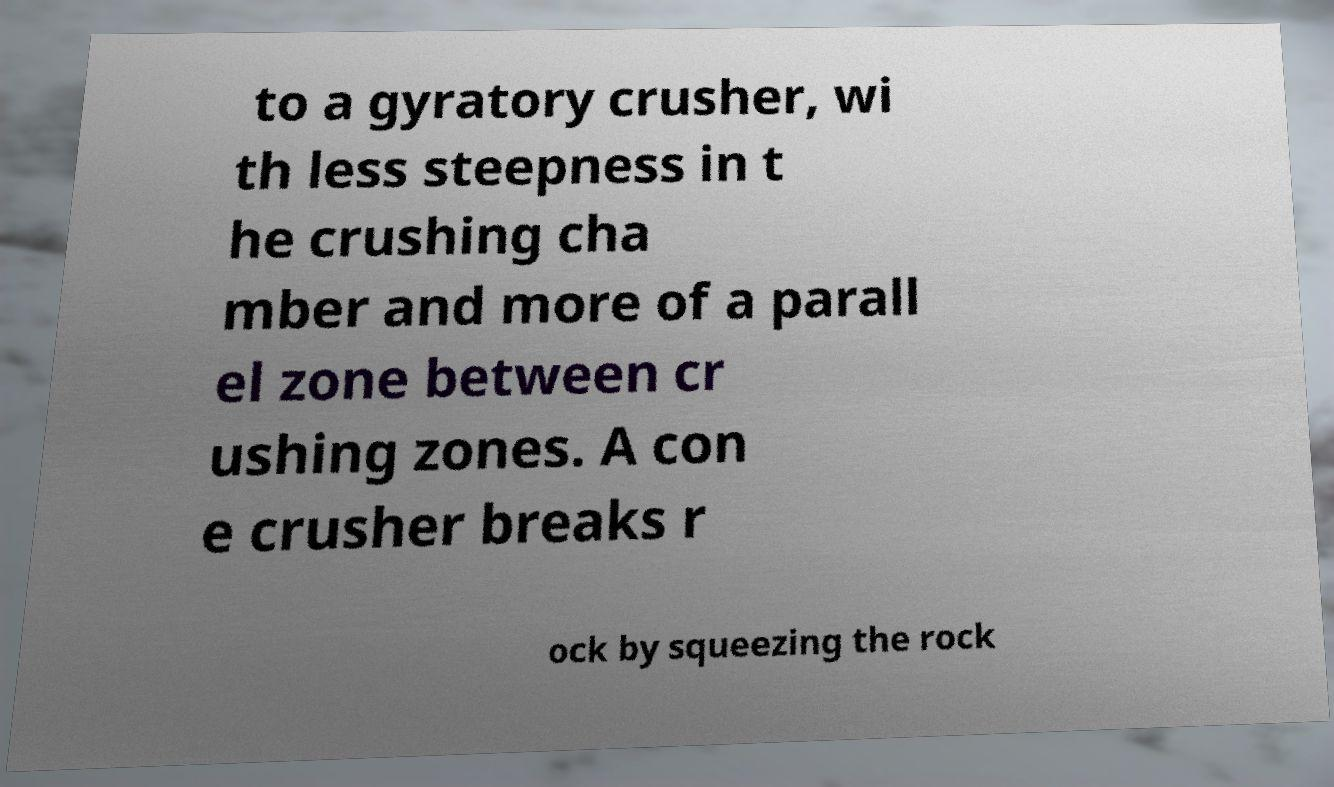Can you accurately transcribe the text from the provided image for me? to a gyratory crusher, wi th less steepness in t he crushing cha mber and more of a parall el zone between cr ushing zones. A con e crusher breaks r ock by squeezing the rock 